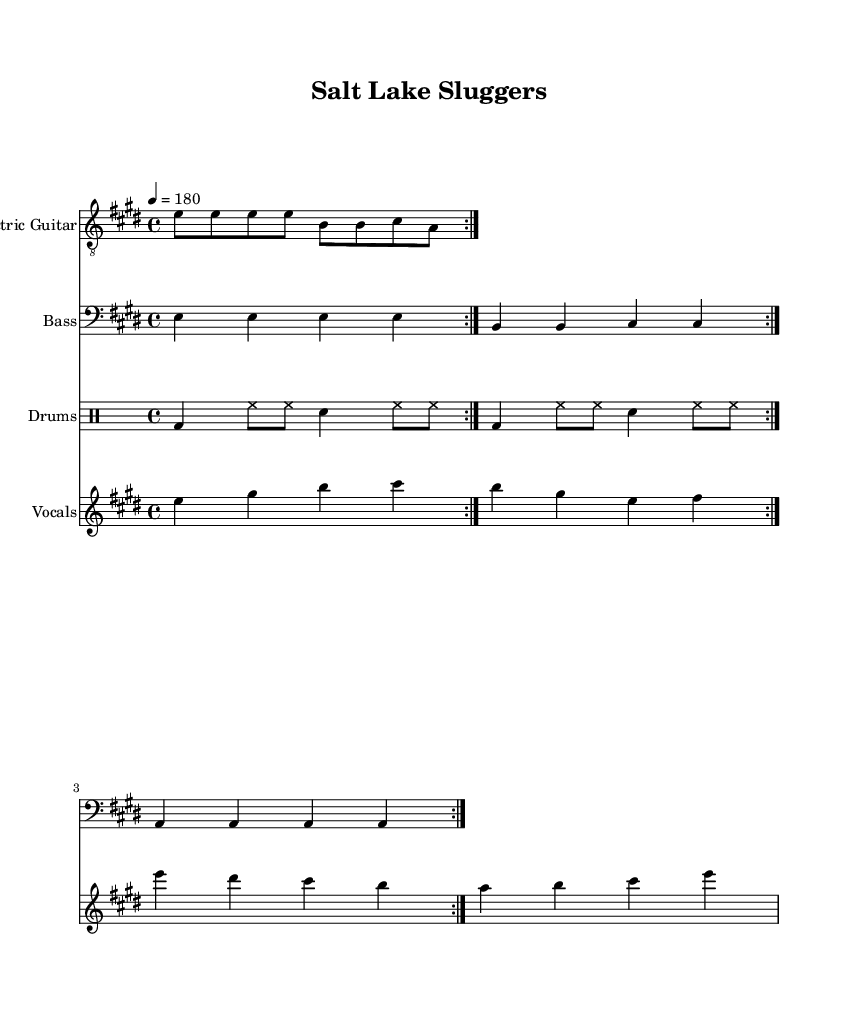What is the key signature of this music? The key signature is E major, which has four sharps (F#, C#, G#, D#). This can be identified from the beginning of the score where the key signature is indicated.
Answer: E major What is the time signature of the piece? The time signature is 4/4, indicated at the beginning of the score. This means there are four beats in each measure and each beat is a quarter note.
Answer: 4/4 What is the tempo marking for this piece? The tempo marking is 180 beats per minute, indicated by the tempo instruction "4 = 180" in the score. This denotes a fast pace typical for punk music.
Answer: 180 How many measures are repeated in the electric guitar part? The electric guitar part repeats for 2 measures as indicated by the "repeat volta 2" instruction in the score. This suggests that the same two measures will be played twice.
Answer: 2 What is the lyrical theme celebrated in this song? The lyrics reflect a nostalgic theme celebrating minor league baseball in Salt Lake City. The words in the verse and chorus reference cheering crowds and the pride of being a baseball town.
Answer: Minor league baseball What instruments are included in this score? The score includes electric guitar, bass, drums, and vocals. Each of these instruments is represented in its own staff, showing that this is a full band arrangement typical for punk rock music.
Answer: Electric guitar, bass, drums, vocals What is the dynamic mood conveyed by the tempo and style of the song? The tempo of 180, combined with the energetic style characteristic of punk music, suggests an upbeat and lively mood. The quick rhythms and celebratory lyrics enhance this feeling, making it suitable for a high-energy live performance.
Answer: Lively 